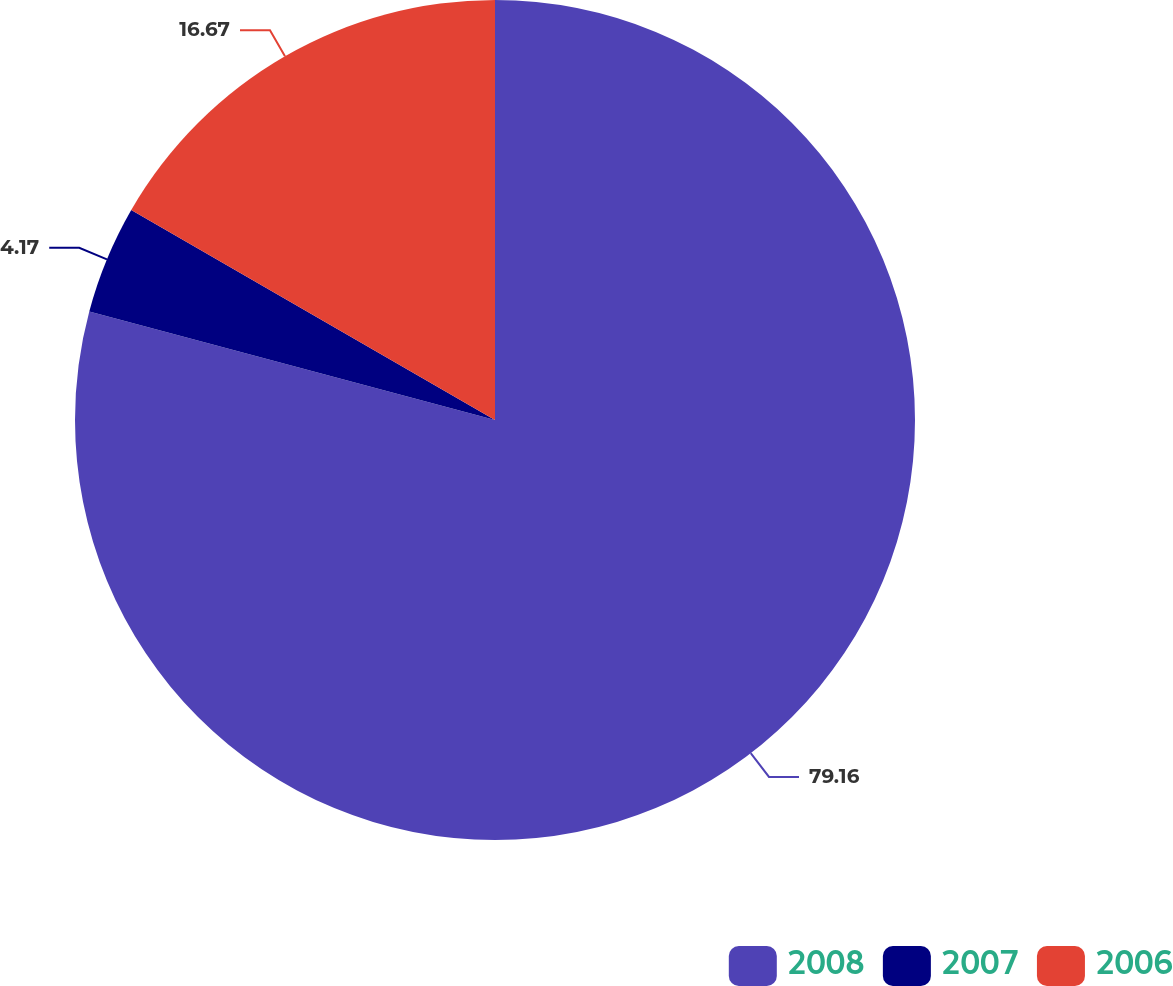Convert chart. <chart><loc_0><loc_0><loc_500><loc_500><pie_chart><fcel>2008<fcel>2007<fcel>2006<nl><fcel>79.17%<fcel>4.17%<fcel>16.67%<nl></chart> 